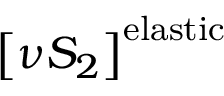<formula> <loc_0><loc_0><loc_500><loc_500>\left [ \nu S _ { 2 } \right ] ^ { e l a s t i c }</formula> 